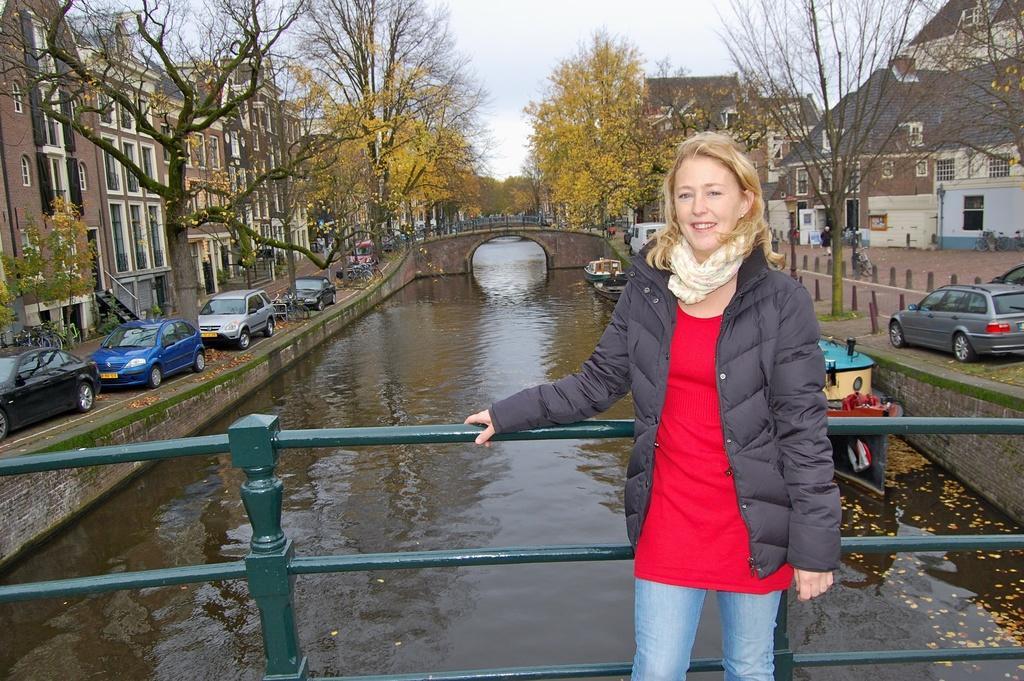Can you describe this image briefly? In this image in the foreground there is a woman standing and smiling and there is railing behind the woman. In the middle there is water. On the left side there are cars, trees and buildings. On the right side there are cars, trees and buildings and in the background there is a bridge, there are trees and the sky is cloudy and on the water there are boats. 